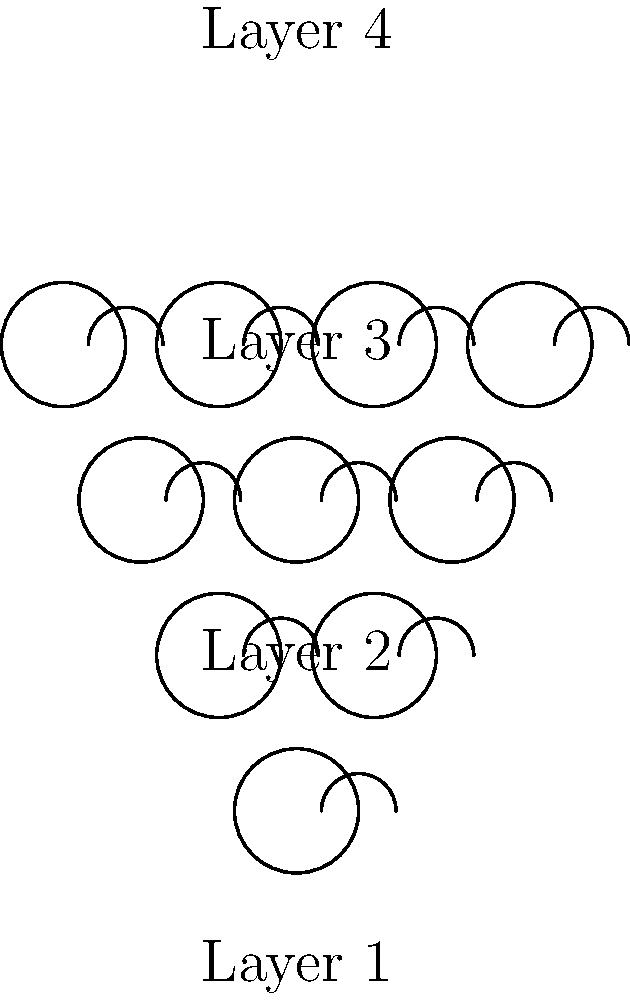For an upcoming royal tea party celebrating the Queen's platinum jubilee, you want to create a pyramid display of teacups. The pyramid will have 4 layers, with each layer containing one more teacup than the layer above it. The top layer has 1 teacup. How many teacups in total are needed to complete this display? Let's approach this step-by-step:

1) First, let's identify the number of teacups in each layer:
   - Layer 4 (top): 1 teacup
   - Layer 3: 2 teacups
   - Layer 2: 3 teacups
   - Layer 1 (bottom): 4 teacups

2) We can see that this forms an arithmetic sequence, where each subsequent layer increases by 1 teacup.

3) To find the total number of teacups, we need to sum this sequence.

4) The formula for the sum of an arithmetic sequence is:
   
   $$ S_n = \frac{n(a_1 + a_n)}{2} $$

   Where $S_n$ is the sum, $n$ is the number of terms, $a_1$ is the first term, and $a_n$ is the last term.

5) In our case:
   $n = 4$ (4 layers)
   $a_1 = 1$ (1 teacup in the top layer)
   $a_n = a_4 = 4$ (4 teacups in the bottom layer)

6) Plugging these into our formula:

   $$ S_4 = \frac{4(1 + 4)}{2} = \frac{4(5)}{2} = \frac{20}{2} = 10 $$

Therefore, 10 teacups are needed to complete the pyramid display.
Answer: 10 teacups 